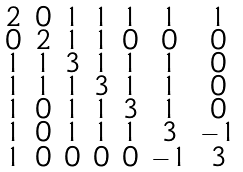<formula> <loc_0><loc_0><loc_500><loc_500>\begin{smallmatrix} 2 & 0 & 1 & 1 & 1 & 1 & 1 \\ 0 & 2 & 1 & 1 & 0 & 0 & 0 \\ 1 & 1 & 3 & 1 & 1 & 1 & 0 \\ 1 & 1 & 1 & 3 & 1 & 1 & 0 \\ 1 & 0 & 1 & 1 & 3 & 1 & 0 \\ 1 & 0 & 1 & 1 & 1 & 3 & - 1 \\ 1 & 0 & 0 & 0 & 0 & - 1 & 3 \end{smallmatrix}</formula> 